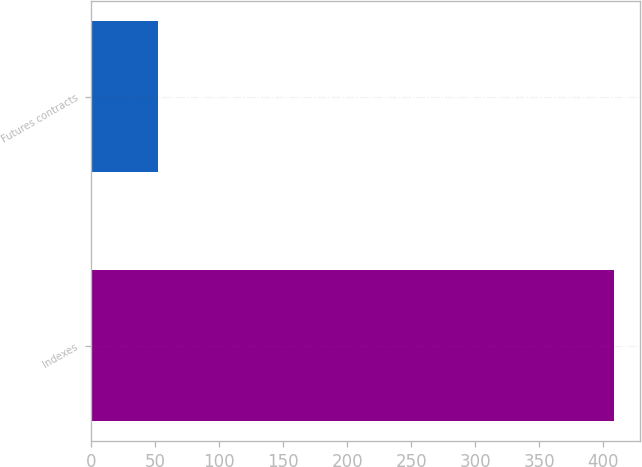Convert chart to OTSL. <chart><loc_0><loc_0><loc_500><loc_500><bar_chart><fcel>Indexes<fcel>Futures contracts<nl><fcel>408.3<fcel>51.7<nl></chart> 